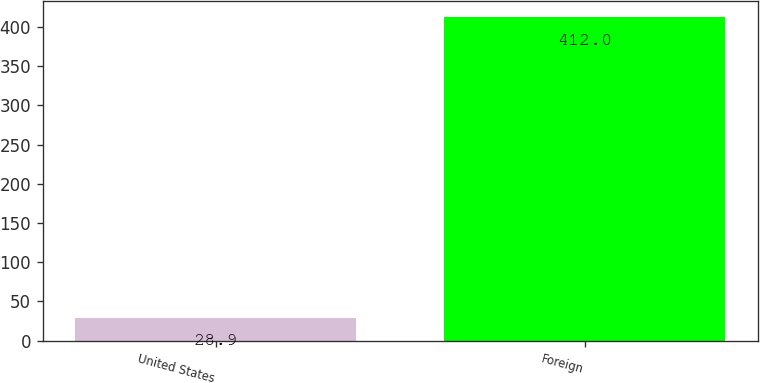Convert chart to OTSL. <chart><loc_0><loc_0><loc_500><loc_500><bar_chart><fcel>United States<fcel>Foreign<nl><fcel>28.9<fcel>412<nl></chart> 